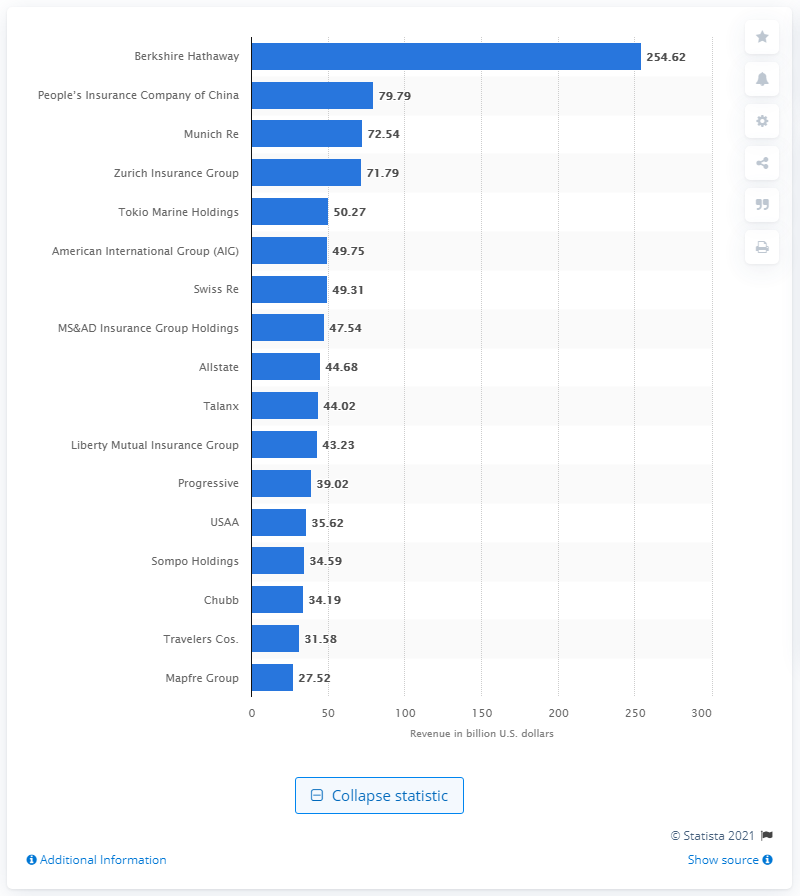Indicate a few pertinent items in this graphic. In 2019, Munich Re reported a revenue of 72.54 million U.S. dollars. In 2019, the most profitable property and casualty insurance company in the world was Berkshire Hathaway. In 2019, Munich Re generated a total revenue of 72.54 million U.S. dollars. In 2019, the revenue of Berkshire Hathaway was 254.62 billion U.S. dollars. 